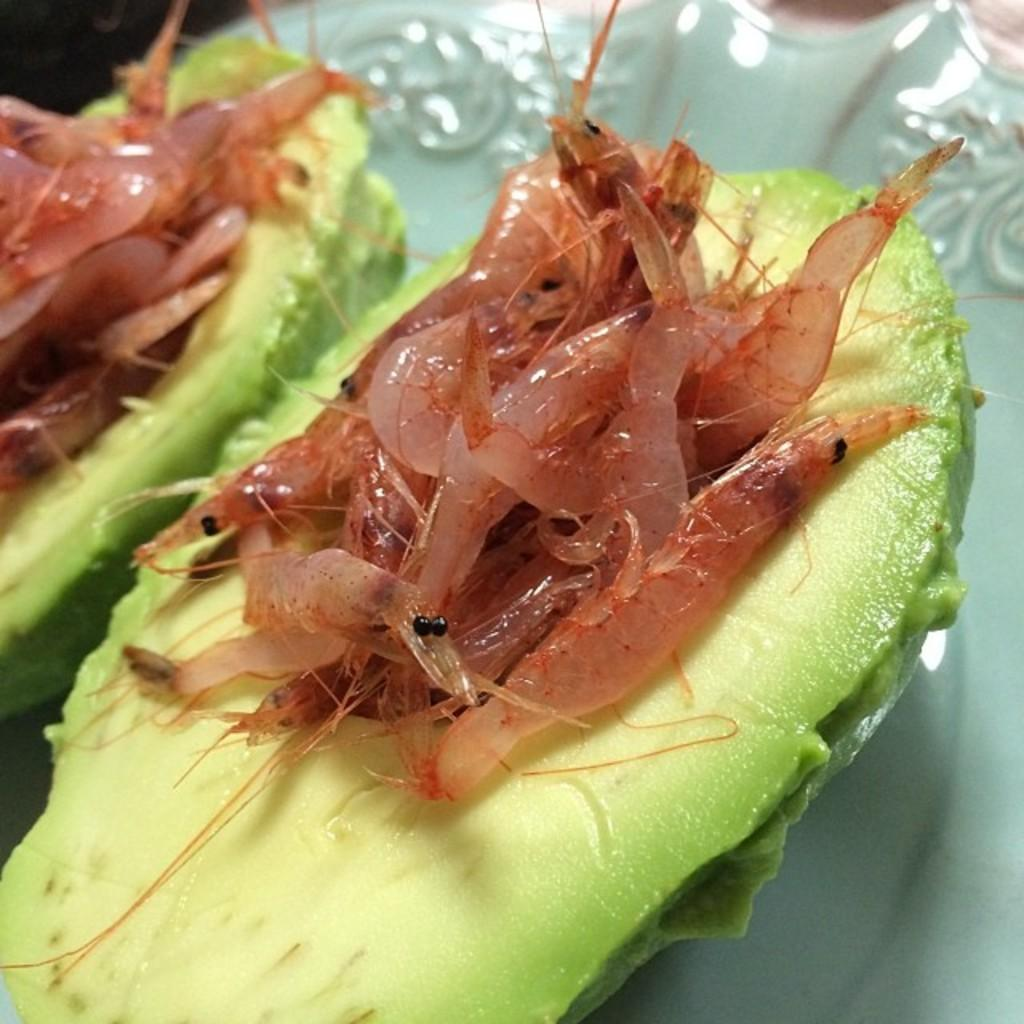What type of fruit is present in the image? There are two avocados in the image. Are there any additional elements on the avocados? Yes, there are krills on the avocados. What type of sport is being played with the avocados in the image? There is no sport being played in the image, as it only features avocados with krills on them. 